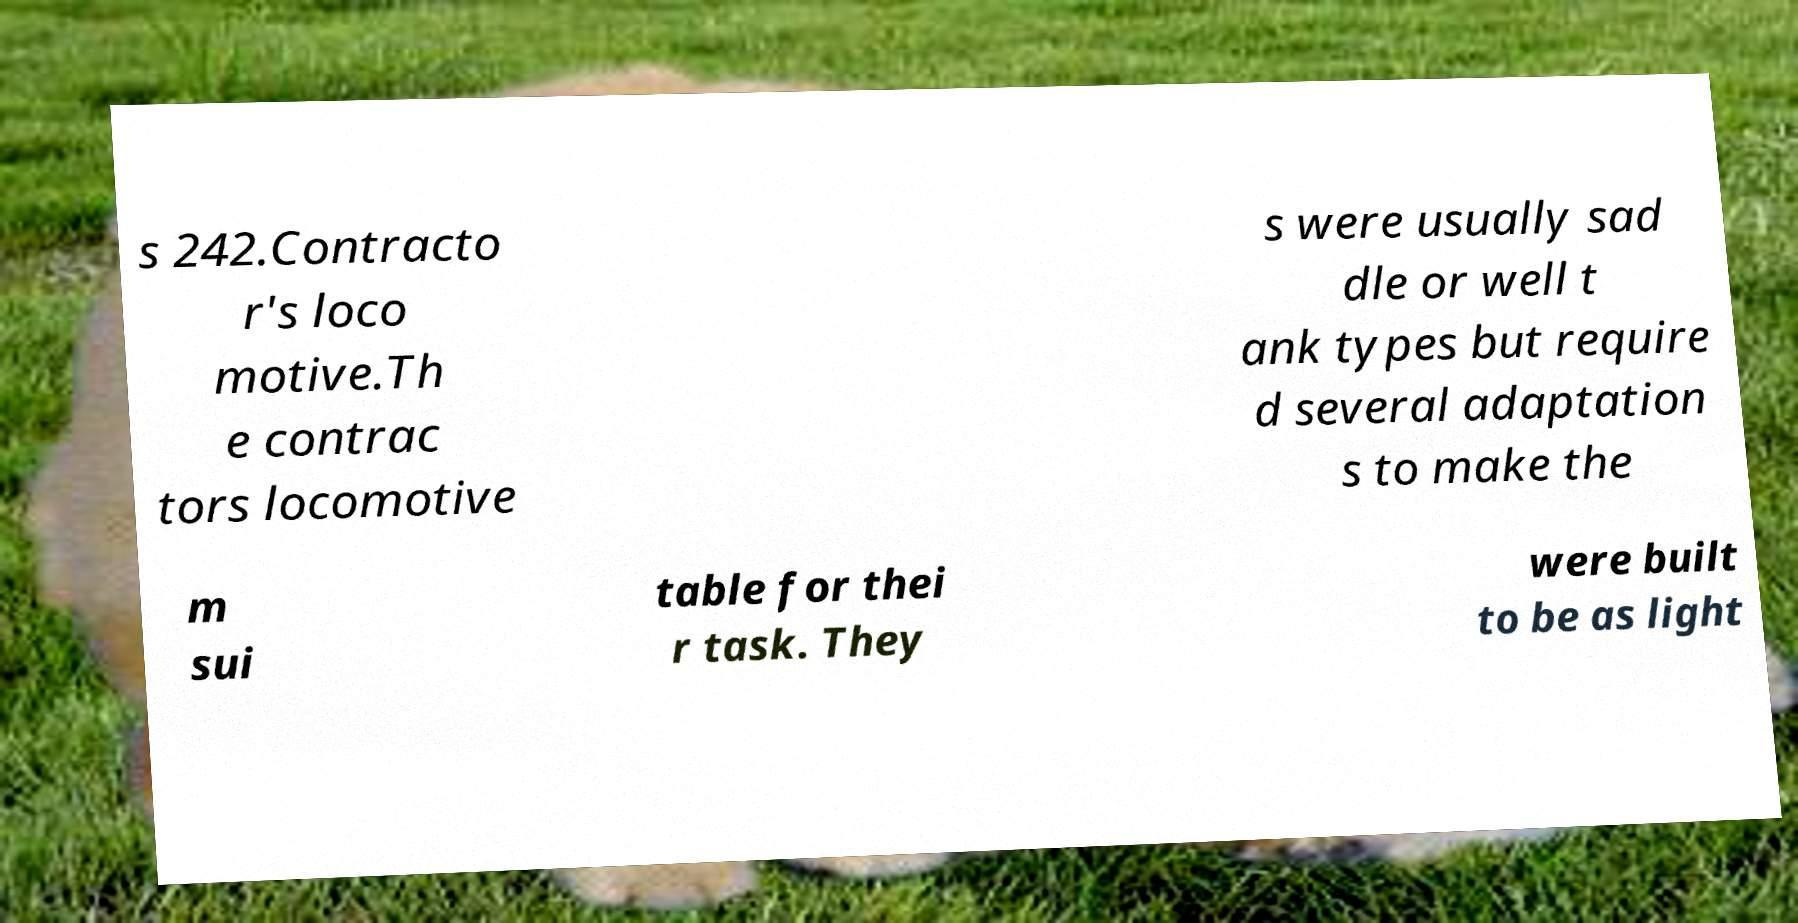Could you assist in decoding the text presented in this image and type it out clearly? s 242.Contracto r's loco motive.Th e contrac tors locomotive s were usually sad dle or well t ank types but require d several adaptation s to make the m sui table for thei r task. They were built to be as light 